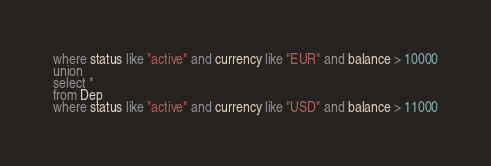<code> <loc_0><loc_0><loc_500><loc_500><_SQL_>where status like "active" and currency like "EUR" and balance > 10000
union
select *
from Dep
where status like "active" and currency like "USD" and balance > 11000
</code> 